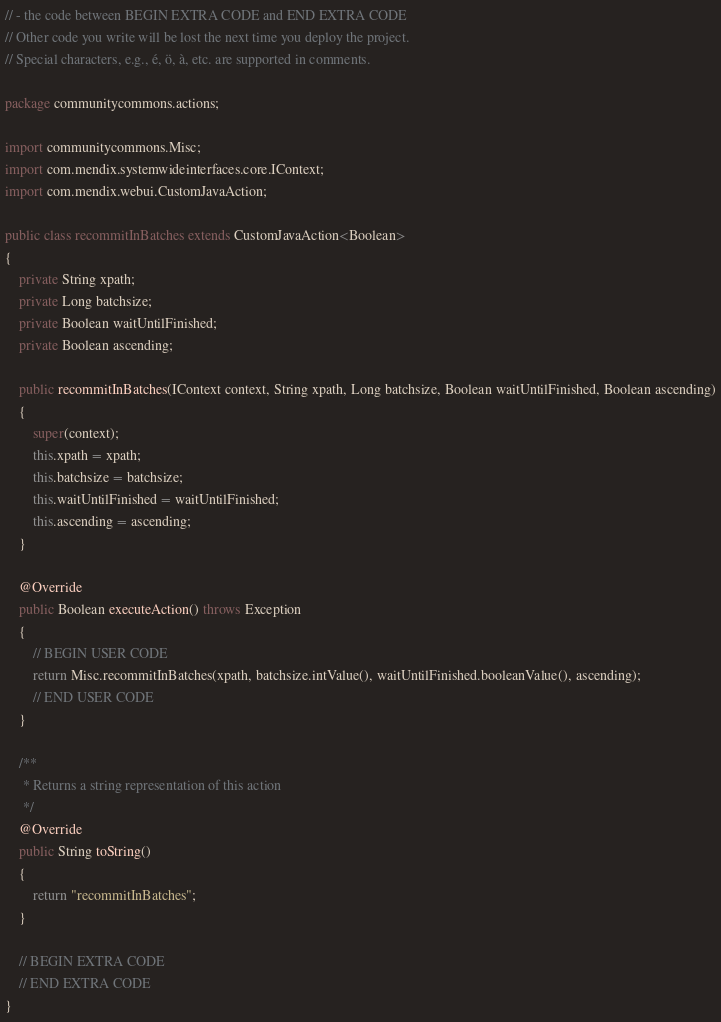Convert code to text. <code><loc_0><loc_0><loc_500><loc_500><_Java_>// - the code between BEGIN EXTRA CODE and END EXTRA CODE
// Other code you write will be lost the next time you deploy the project.
// Special characters, e.g., é, ö, à, etc. are supported in comments.

package communitycommons.actions;

import communitycommons.Misc;
import com.mendix.systemwideinterfaces.core.IContext;
import com.mendix.webui.CustomJavaAction;

public class recommitInBatches extends CustomJavaAction<Boolean>
{
	private String xpath;
	private Long batchsize;
	private Boolean waitUntilFinished;
	private Boolean ascending;

	public recommitInBatches(IContext context, String xpath, Long batchsize, Boolean waitUntilFinished, Boolean ascending)
	{
		super(context);
		this.xpath = xpath;
		this.batchsize = batchsize;
		this.waitUntilFinished = waitUntilFinished;
		this.ascending = ascending;
	}

	@Override
	public Boolean executeAction() throws Exception
	{
		// BEGIN USER CODE
		return Misc.recommitInBatches(xpath, batchsize.intValue(), waitUntilFinished.booleanValue(), ascending);
		// END USER CODE
	}

	/**
	 * Returns a string representation of this action
	 */
	@Override
	public String toString()
	{
		return "recommitInBatches";
	}

	// BEGIN EXTRA CODE
	// END EXTRA CODE
}
</code> 